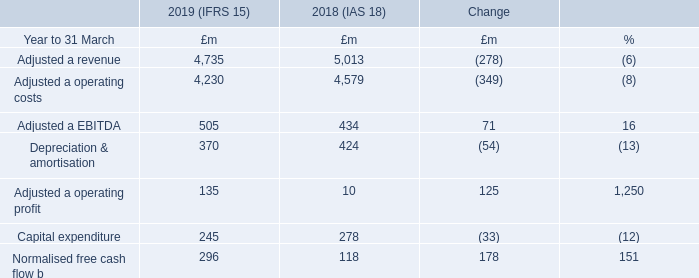Global Services
Adjusteda revenue £4,735m
£4,735m
Adjusteda operating profit
£135m
Global Services operates in a global market that continues to experience high levels of change driven by both rapid technology innovation and a dynamic competitive landscape. Customers’ demands continue to evolve towards more flexible, on-demand models and new cloud-based and software-defined networking solutions. We continue to execute our Digital Global Services transformation programme to focus our business, standardise our operations, transform our underlying infrastructure, and provide innovative solutions to address the changing demands of our customers. We are focused on around 800 multinational companies and financial institutions served by three global industry verticals.
Adjusteda revenue for the year was down 6%, in line with our strategy to de-emphasise low margin business and including the impact of divestments. This includes a £35m negative impact from foreign exchange movements, primarily reflecting lower IP Exchange volumes and equipment sales.
Adjusteda operating costs for the year were down 8% mainly reflecting the decline in IP Exchange volumes and equipment sales and lower labour costs from our ongoing restructuring programme. Adjusteda EBITDA for the year was up £71m reflecting the reduction in operating costs and certain one-offs, more than offsetting the impact of lower revenue.
Depreciation and amortisation was down 13% for the year due to closure of certain projects in the prior year.
Capital expenditure was down 12% for the year reflecting ongoing rationalisation and our strategy to become a more asset light business. Normalised free cash flowb for the year improved by 151% to £296m, reflecting higher EBITDA, lower capital expenditure and improved working capital.
Total order intake was £3.3bn, down 15% year on year continuing to reflect a shift in customer behaviour, including shorter contract lengths and greater prevalence of usage-based terms.
a Adjusted measures exclude specific items, as explained in the Additional Information on page 185. b Free cash flow after net interest paid, before pension deficit payments (including the cash tax benefit of pension deficit payments) and specific items. c Openreach comparatives have been re-presented to reflect the transfer of Northern Ireland Networks from Enterprise to Openreach.
What is the  Adjusted a revenue for 2019?
Answer scale should be: million. 4,735. What is the reason for Adjusteda operating costs percentage decrease? Mainly reflecting the decline in ip exchange volumes and equipment sales and lower labour costs from our ongoing restructuring programme. What is the Capital expenditure for 2019?
Answer scale should be: million. 245. What was the average Adjusted EBITDA for 2018 and 2019?
Answer scale should be: million. (505 + 434) / 2
Answer: 469.5. What  was the EBITDA margin in 2019? 505 / 4,735
Answer: 0.11. What is the average Adjusteda operating costs for 2018 and 2019?
Answer scale should be: million. (4,230 + 4,579) / 2
Answer: 4404.5. 